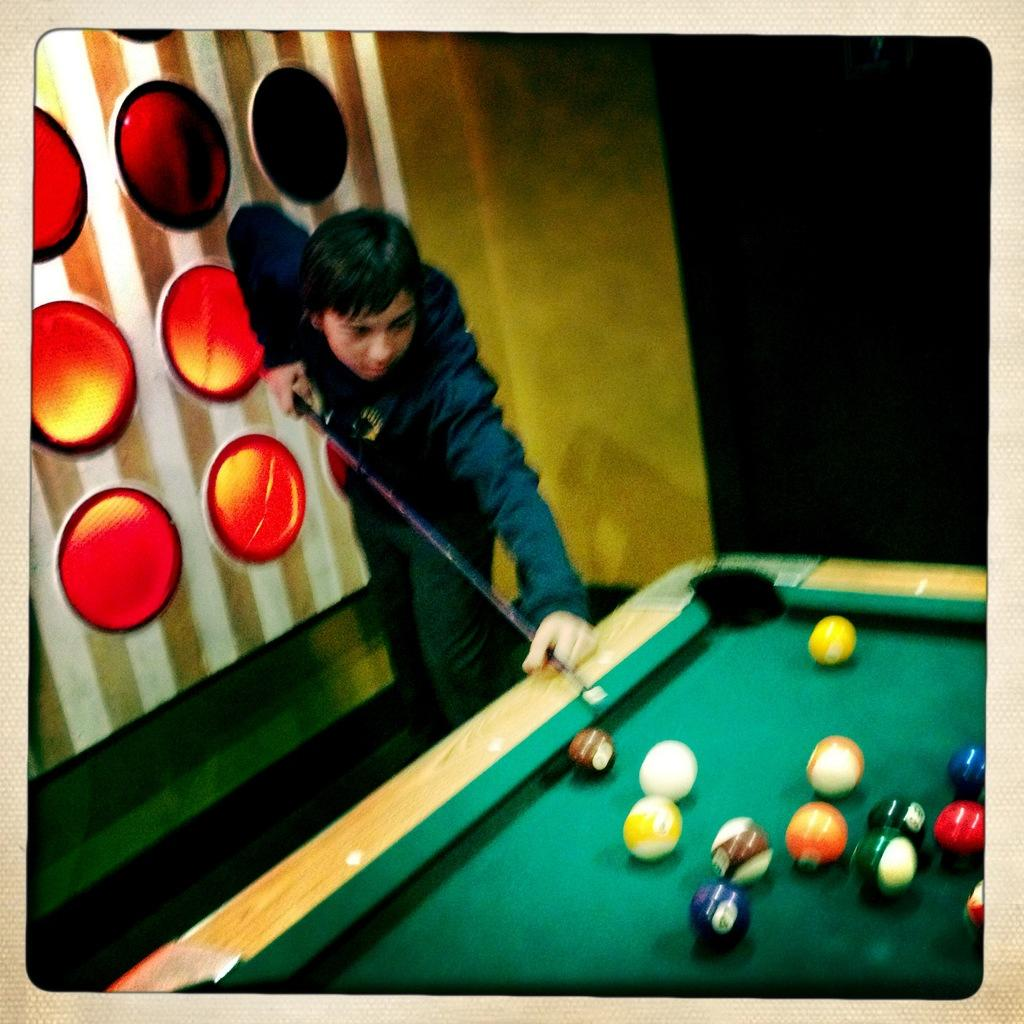What is the main subject of the image? There is a person in the image. What is the person holding in his hand? The person is holding a stick in his hand. What is on the table in the image? There are balls on the table. What can be seen in the background of the image? There is a wall in the background of the image. What type of organization is the person affiliated with in the image? There is no information about the person's affiliation or any organization in the image. What type of polish is the person using on the stick in the image? There is no indication of any polish being used on the stick in the image. 